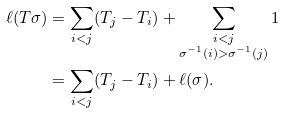Convert formula to latex. <formula><loc_0><loc_0><loc_500><loc_500>\ell ( T \sigma ) & = \sum _ { i < j } ( T _ { j } - T _ { i } ) + \sum _ { \substack { i < j \\ \sigma ^ { - 1 } ( i ) > \sigma ^ { - 1 } ( j ) } } 1 \\ & = \sum _ { i < j } ( T _ { j } - T _ { i } ) + \ell ( \sigma ) .</formula> 